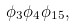Convert formula to latex. <formula><loc_0><loc_0><loc_500><loc_500>\phi _ { 3 } \phi _ { 4 } \phi _ { 1 5 } ,</formula> 